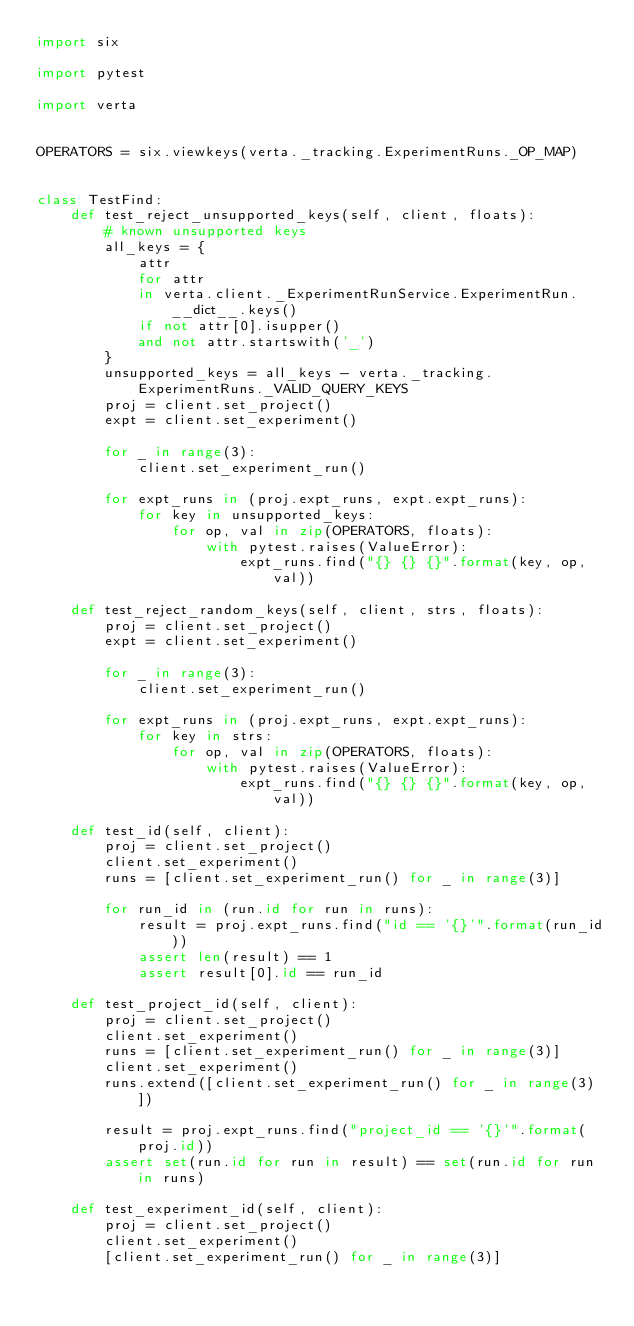Convert code to text. <code><loc_0><loc_0><loc_500><loc_500><_Python_>import six

import pytest

import verta


OPERATORS = six.viewkeys(verta._tracking.ExperimentRuns._OP_MAP)


class TestFind:
    def test_reject_unsupported_keys(self, client, floats):
        # known unsupported keys
        all_keys = {
            attr
            for attr
            in verta.client._ExperimentRunService.ExperimentRun.__dict__.keys()
            if not attr[0].isupper()
            and not attr.startswith('_')
        }
        unsupported_keys = all_keys - verta._tracking.ExperimentRuns._VALID_QUERY_KEYS
        proj = client.set_project()
        expt = client.set_experiment()

        for _ in range(3):
            client.set_experiment_run()

        for expt_runs in (proj.expt_runs, expt.expt_runs):
            for key in unsupported_keys:
                for op, val in zip(OPERATORS, floats):
                    with pytest.raises(ValueError):
                        expt_runs.find("{} {} {}".format(key, op, val))

    def test_reject_random_keys(self, client, strs, floats):
        proj = client.set_project()
        expt = client.set_experiment()

        for _ in range(3):
            client.set_experiment_run()

        for expt_runs in (proj.expt_runs, expt.expt_runs):
            for key in strs:
                for op, val in zip(OPERATORS, floats):
                    with pytest.raises(ValueError):
                        expt_runs.find("{} {} {}".format(key, op, val))

    def test_id(self, client):
        proj = client.set_project()
        client.set_experiment()
        runs = [client.set_experiment_run() for _ in range(3)]

        for run_id in (run.id for run in runs):
            result = proj.expt_runs.find("id == '{}'".format(run_id))
            assert len(result) == 1
            assert result[0].id == run_id

    def test_project_id(self, client):
        proj = client.set_project()
        client.set_experiment()
        runs = [client.set_experiment_run() for _ in range(3)]
        client.set_experiment()
        runs.extend([client.set_experiment_run() for _ in range(3)])

        result = proj.expt_runs.find("project_id == '{}'".format(proj.id))
        assert set(run.id for run in result) == set(run.id for run in runs)

    def test_experiment_id(self, client):
        proj = client.set_project()
        client.set_experiment()
        [client.set_experiment_run() for _ in range(3)]</code> 